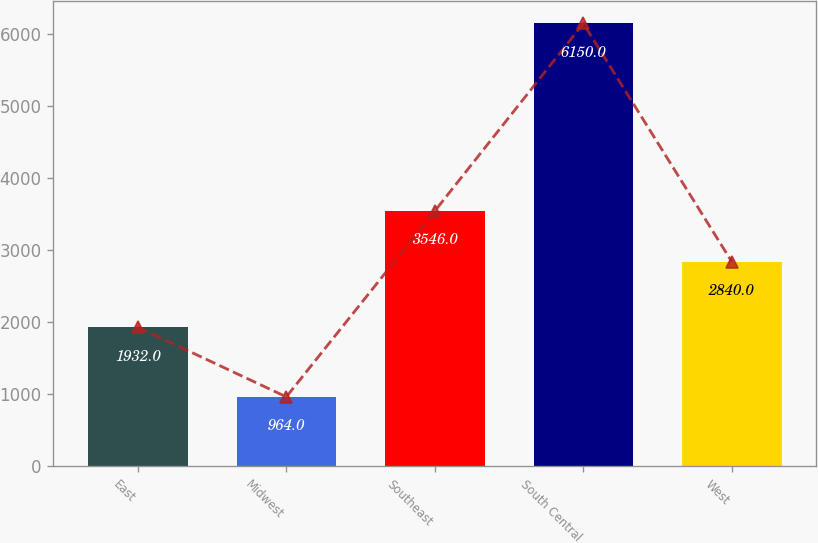Convert chart to OTSL. <chart><loc_0><loc_0><loc_500><loc_500><bar_chart><fcel>East<fcel>Midwest<fcel>Southeast<fcel>South Central<fcel>West<nl><fcel>1932<fcel>964<fcel>3546<fcel>6150<fcel>2840<nl></chart> 